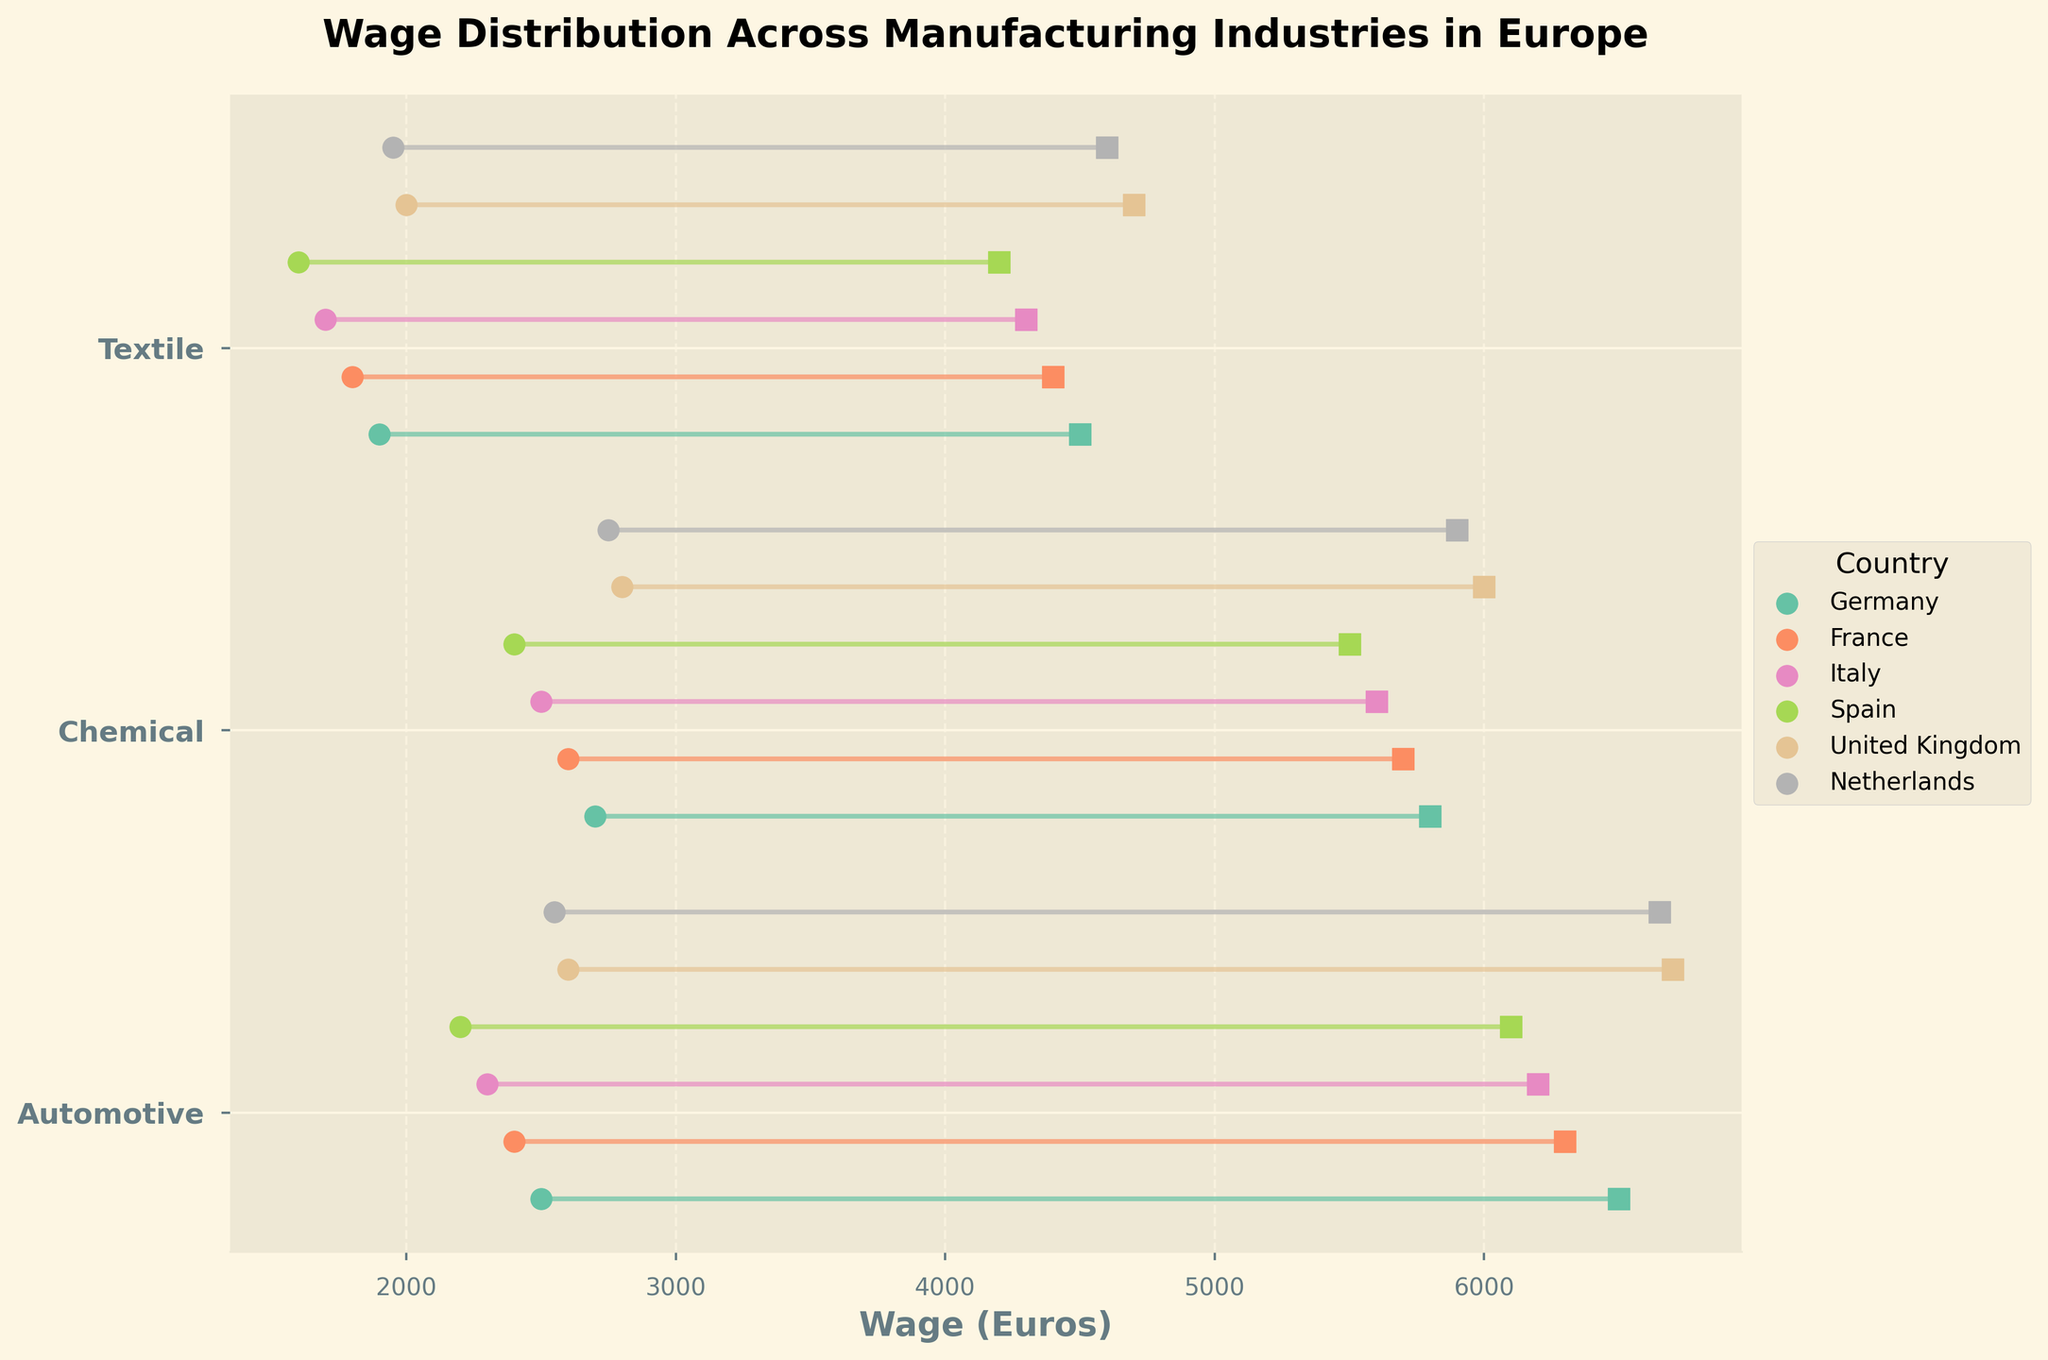Which country has the highest maximum wage in the Automotive industry? The plot shows maximum wages for the Automotive industry in different countries. The United Kingdom has the highest maximum wage.
Answer: United Kingdom What is the range of wages in the Textile industry in Spain? The range is calculated as the difference between the maximum and minimum wages. The minimum wage for Spain in the Textile industry is 1600 Euros and the maximum is 4200 Euros. So, the range is 4200 - 1600 = 2600 Euros.
Answer: 2600 Euros Which country shows the smallest range of wages in the Chemical industry? By examining the lengths of the line segments connecting minimum and maximum wages in the Chemical industry for each country, Italy has the smallest range from 2500 to 5600 Euros.
Answer: Italy Are the minimum wages in the Automotive industry higher than those in the Textile industry across all countries? By comparing the minimum wages for the Automotive and Textile industries across each country: Germany (2500 vs 1900), France (2400 vs 1800), Italy (2300 vs 1700), Spain (2200 vs 1600), United Kingdom (2600 vs 2000), Netherlands (2550 vs 1950). Automotive industry minimum wages are higher in each country.
Answer: Yes Which industry in Germany has the overall lowest wage? To find the overall lowest wage, check the minimum wages for all industries in Germany: Automotive (2500), Chemical (2700), Textile (1900). Germany's Textile industry has the lowest minimum wage of 1900 Euros.
Answer: Textile What is the average maximum wage in the Chemical industry across all countries? Add the maximum wages in the Chemical industry for all countries: Germany (5800), France (5700), Italy (5600), Spain (5500), United Kingdom (6000), Netherlands (5900). Sum = 34500. Divide by number of countries (6): 34500 / 6.
Answer: 5750 Euros Which industry shows the most wage disparity within the same country? Wage disparity is indicated by the length of the line segments. In the United Kingdom's Automotive industry, the wages range from 2600 to 6700 Euros, showing the largest disparity of 4100 Euros.
Answer: Automotive in United Kingdom How does the maximum wage in the Netherlands’ Chemical industry compare to the minimum wage in Germany’s Chemical industry? The maximum wage in the Netherlands’ Chemical industry is 5900 Euros, and the minimum wage in Germany’s Chemical industry is 2700 Euros. 5900 is higher than 2700 Euros.
Answer: Higher What is the difference between the highest and lowest maximum wages in the Automotive industry? Identify the highest and lowest maximum wages in the Automotive industry: United Kingdom (6700 Euros) and Spain (6100 Euros). Difference = 6700 - 6100.
Answer: 600 Euros 